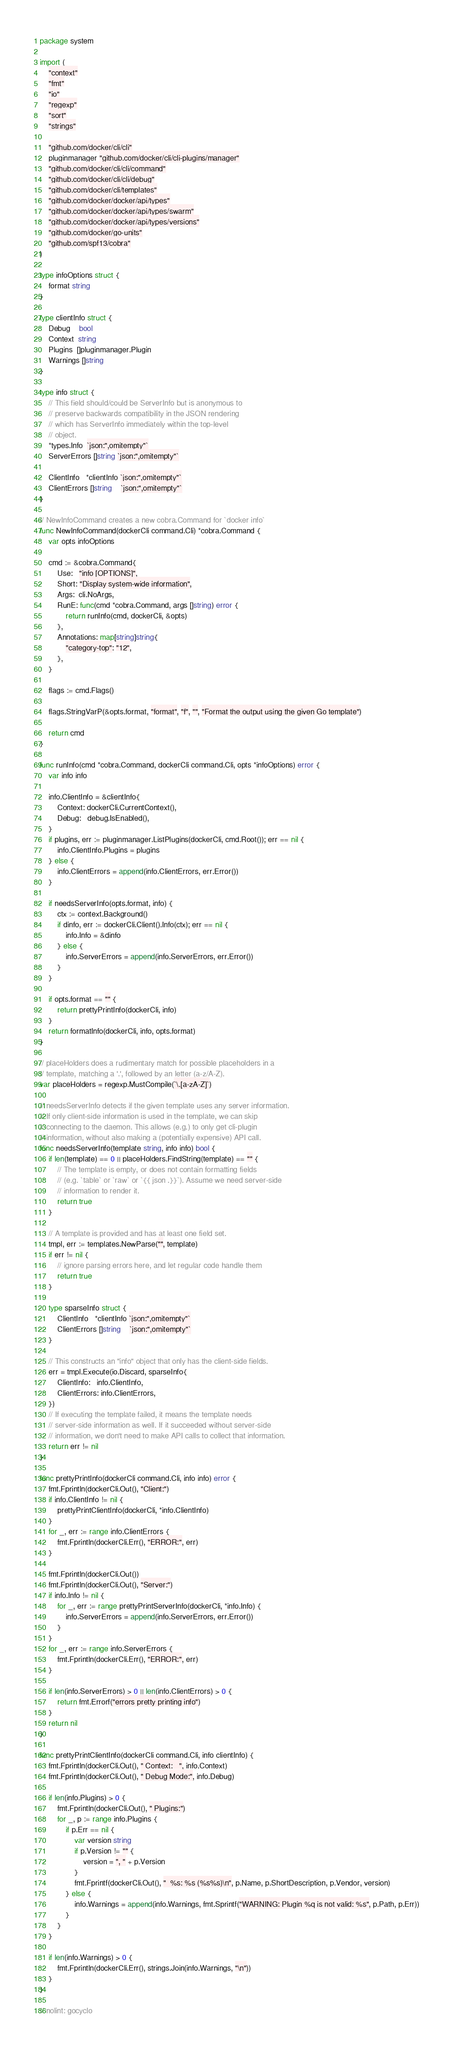<code> <loc_0><loc_0><loc_500><loc_500><_Go_>package system

import (
	"context"
	"fmt"
	"io"
	"regexp"
	"sort"
	"strings"

	"github.com/docker/cli/cli"
	pluginmanager "github.com/docker/cli/cli-plugins/manager"
	"github.com/docker/cli/cli/command"
	"github.com/docker/cli/cli/debug"
	"github.com/docker/cli/templates"
	"github.com/docker/docker/api/types"
	"github.com/docker/docker/api/types/swarm"
	"github.com/docker/docker/api/types/versions"
	"github.com/docker/go-units"
	"github.com/spf13/cobra"
)

type infoOptions struct {
	format string
}

type clientInfo struct {
	Debug    bool
	Context  string
	Plugins  []pluginmanager.Plugin
	Warnings []string
}

type info struct {
	// This field should/could be ServerInfo but is anonymous to
	// preserve backwards compatibility in the JSON rendering
	// which has ServerInfo immediately within the top-level
	// object.
	*types.Info  `json:",omitempty"`
	ServerErrors []string `json:",omitempty"`

	ClientInfo   *clientInfo `json:",omitempty"`
	ClientErrors []string    `json:",omitempty"`
}

// NewInfoCommand creates a new cobra.Command for `docker info`
func NewInfoCommand(dockerCli command.Cli) *cobra.Command {
	var opts infoOptions

	cmd := &cobra.Command{
		Use:   "info [OPTIONS]",
		Short: "Display system-wide information",
		Args:  cli.NoArgs,
		RunE: func(cmd *cobra.Command, args []string) error {
			return runInfo(cmd, dockerCli, &opts)
		},
		Annotations: map[string]string{
			"category-top": "12",
		},
	}

	flags := cmd.Flags()

	flags.StringVarP(&opts.format, "format", "f", "", "Format the output using the given Go template")

	return cmd
}

func runInfo(cmd *cobra.Command, dockerCli command.Cli, opts *infoOptions) error {
	var info info

	info.ClientInfo = &clientInfo{
		Context: dockerCli.CurrentContext(),
		Debug:   debug.IsEnabled(),
	}
	if plugins, err := pluginmanager.ListPlugins(dockerCli, cmd.Root()); err == nil {
		info.ClientInfo.Plugins = plugins
	} else {
		info.ClientErrors = append(info.ClientErrors, err.Error())
	}

	if needsServerInfo(opts.format, info) {
		ctx := context.Background()
		if dinfo, err := dockerCli.Client().Info(ctx); err == nil {
			info.Info = &dinfo
		} else {
			info.ServerErrors = append(info.ServerErrors, err.Error())
		}
	}

	if opts.format == "" {
		return prettyPrintInfo(dockerCli, info)
	}
	return formatInfo(dockerCli, info, opts.format)
}

// placeHolders does a rudimentary match for possible placeholders in a
// template, matching a '.', followed by an letter (a-z/A-Z).
var placeHolders = regexp.MustCompile(`\.[a-zA-Z]`)

// needsServerInfo detects if the given template uses any server information.
// If only client-side information is used in the template, we can skip
// connecting to the daemon. This allows (e.g.) to only get cli-plugin
// information, without also making a (potentially expensive) API call.
func needsServerInfo(template string, info info) bool {
	if len(template) == 0 || placeHolders.FindString(template) == "" {
		// The template is empty, or does not contain formatting fields
		// (e.g. `table` or `raw` or `{{ json .}}`). Assume we need server-side
		// information to render it.
		return true
	}

	// A template is provided and has at least one field set.
	tmpl, err := templates.NewParse("", template)
	if err != nil {
		// ignore parsing errors here, and let regular code handle them
		return true
	}

	type sparseInfo struct {
		ClientInfo   *clientInfo `json:",omitempty"`
		ClientErrors []string    `json:",omitempty"`
	}

	// This constructs an "info" object that only has the client-side fields.
	err = tmpl.Execute(io.Discard, sparseInfo{
		ClientInfo:   info.ClientInfo,
		ClientErrors: info.ClientErrors,
	})
	// If executing the template failed, it means the template needs
	// server-side information as well. If it succeeded without server-side
	// information, we don't need to make API calls to collect that information.
	return err != nil
}

func prettyPrintInfo(dockerCli command.Cli, info info) error {
	fmt.Fprintln(dockerCli.Out(), "Client:")
	if info.ClientInfo != nil {
		prettyPrintClientInfo(dockerCli, *info.ClientInfo)
	}
	for _, err := range info.ClientErrors {
		fmt.Fprintln(dockerCli.Err(), "ERROR:", err)
	}

	fmt.Fprintln(dockerCli.Out())
	fmt.Fprintln(dockerCli.Out(), "Server:")
	if info.Info != nil {
		for _, err := range prettyPrintServerInfo(dockerCli, *info.Info) {
			info.ServerErrors = append(info.ServerErrors, err.Error())
		}
	}
	for _, err := range info.ServerErrors {
		fmt.Fprintln(dockerCli.Err(), "ERROR:", err)
	}

	if len(info.ServerErrors) > 0 || len(info.ClientErrors) > 0 {
		return fmt.Errorf("errors pretty printing info")
	}
	return nil
}

func prettyPrintClientInfo(dockerCli command.Cli, info clientInfo) {
	fmt.Fprintln(dockerCli.Out(), " Context:   ", info.Context)
	fmt.Fprintln(dockerCli.Out(), " Debug Mode:", info.Debug)

	if len(info.Plugins) > 0 {
		fmt.Fprintln(dockerCli.Out(), " Plugins:")
		for _, p := range info.Plugins {
			if p.Err == nil {
				var version string
				if p.Version != "" {
					version = ", " + p.Version
				}
				fmt.Fprintf(dockerCli.Out(), "  %s: %s (%s%s)\n", p.Name, p.ShortDescription, p.Vendor, version)
			} else {
				info.Warnings = append(info.Warnings, fmt.Sprintf("WARNING: Plugin %q is not valid: %s", p.Path, p.Err))
			}
		}
	}

	if len(info.Warnings) > 0 {
		fmt.Fprintln(dockerCli.Err(), strings.Join(info.Warnings, "\n"))
	}
}

// nolint: gocyclo</code> 